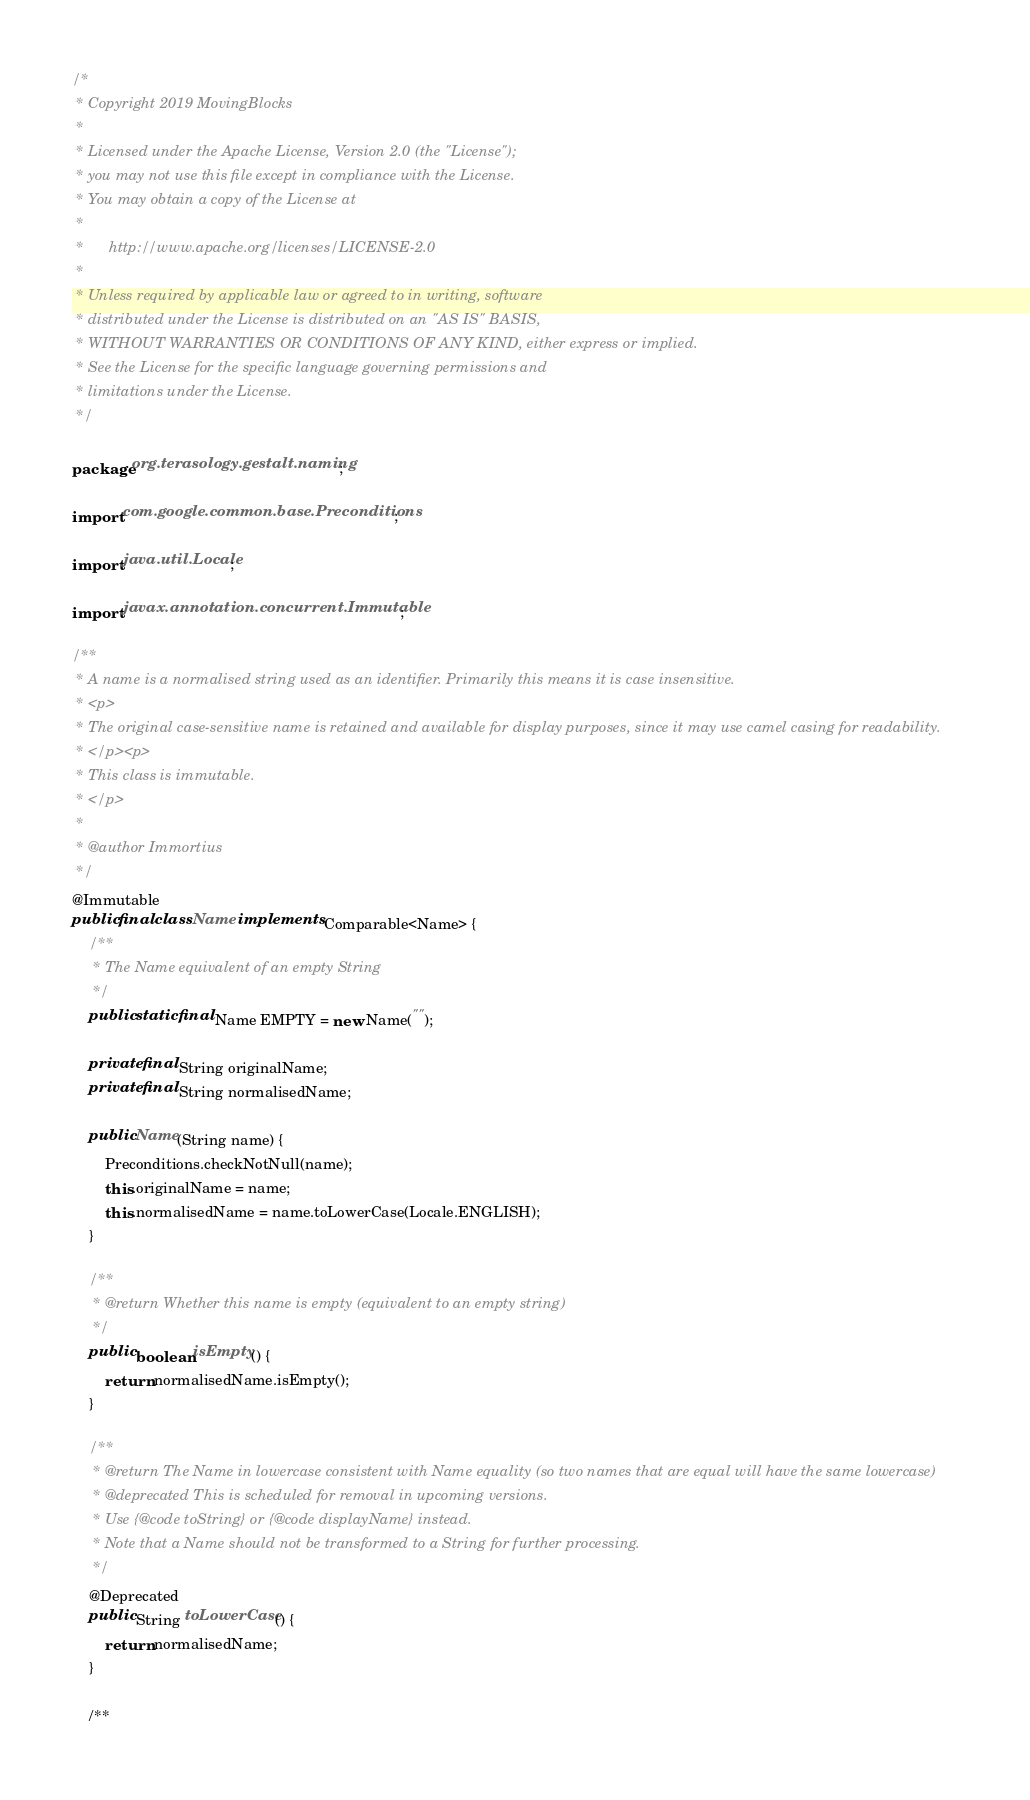Convert code to text. <code><loc_0><loc_0><loc_500><loc_500><_Java_>/*
 * Copyright 2019 MovingBlocks
 *
 * Licensed under the Apache License, Version 2.0 (the "License");
 * you may not use this file except in compliance with the License.
 * You may obtain a copy of the License at
 *
 *      http://www.apache.org/licenses/LICENSE-2.0
 *
 * Unless required by applicable law or agreed to in writing, software
 * distributed under the License is distributed on an "AS IS" BASIS,
 * WITHOUT WARRANTIES OR CONDITIONS OF ANY KIND, either express or implied.
 * See the License for the specific language governing permissions and
 * limitations under the License.
 */

package org.terasology.gestalt.naming;

import com.google.common.base.Preconditions;

import java.util.Locale;

import javax.annotation.concurrent.Immutable;

/**
 * A name is a normalised string used as an identifier. Primarily this means it is case insensitive.
 * <p>
 * The original case-sensitive name is retained and available for display purposes, since it may use camel casing for readability.
 * </p><p>
 * This class is immutable.
 * </p>
 *
 * @author Immortius
 */
@Immutable
public final class Name implements Comparable<Name> {
    /**
     * The Name equivalent of an empty String
     */
    public static final Name EMPTY = new Name("");

    private final String originalName;
    private final String normalisedName;

    public Name(String name) {
        Preconditions.checkNotNull(name);
        this.originalName = name;
        this.normalisedName = name.toLowerCase(Locale.ENGLISH);
    }

    /**
     * @return Whether this name is empty (equivalent to an empty string)
     */
    public boolean isEmpty() {
        return normalisedName.isEmpty();
    }

    /**
     * @return The Name in lowercase consistent with Name equality (so two names that are equal will have the same lowercase)
     * @deprecated This is scheduled for removal in upcoming versions.
     * Use {@code toString} or {@code displayName} instead.
     * Note that a Name should not be transformed to a String for further processing.
     */
    @Deprecated
    public String toLowerCase() {
        return normalisedName;
    }

    /**</code> 